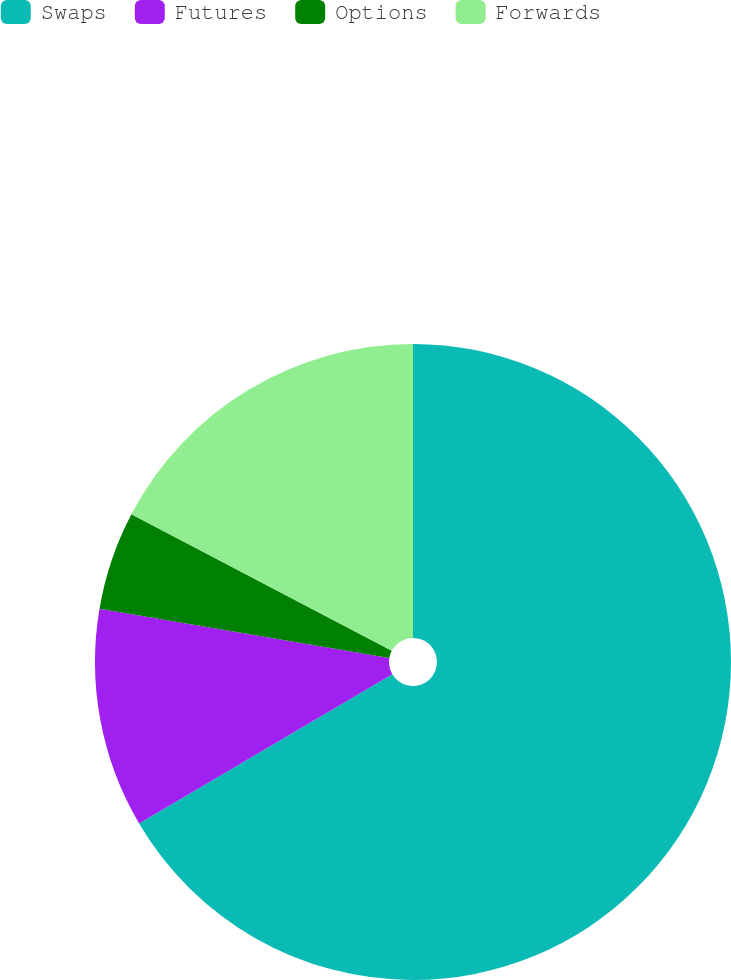Convert chart to OTSL. <chart><loc_0><loc_0><loc_500><loc_500><pie_chart><fcel>Swaps<fcel>Futures<fcel>Options<fcel>Forwards<nl><fcel>66.52%<fcel>11.16%<fcel>5.01%<fcel>17.31%<nl></chart> 